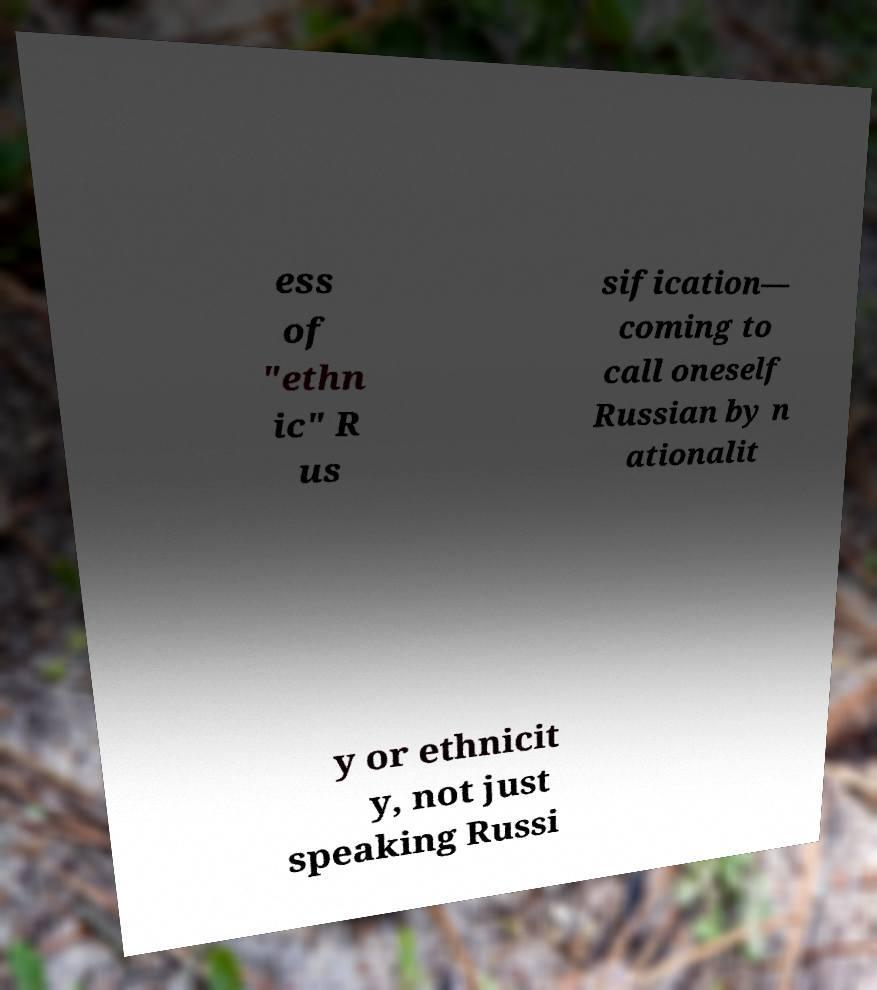What messages or text are displayed in this image? I need them in a readable, typed format. ess of "ethn ic" R us sification— coming to call oneself Russian by n ationalit y or ethnicit y, not just speaking Russi 